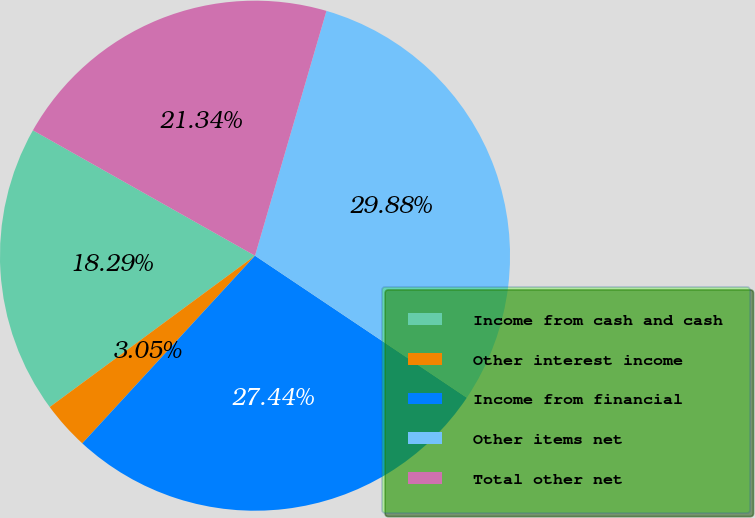Convert chart. <chart><loc_0><loc_0><loc_500><loc_500><pie_chart><fcel>Income from cash and cash<fcel>Other interest income<fcel>Income from financial<fcel>Other items net<fcel>Total other net<nl><fcel>18.29%<fcel>3.05%<fcel>27.44%<fcel>29.88%<fcel>21.34%<nl></chart> 